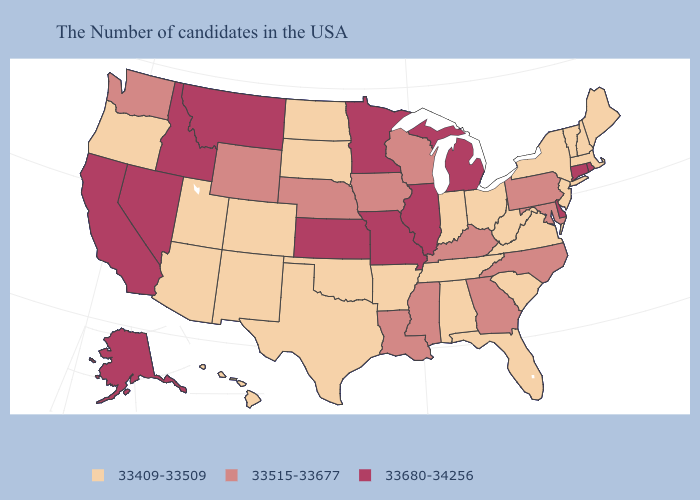What is the value of Minnesota?
Answer briefly. 33680-34256. Name the states that have a value in the range 33680-34256?
Concise answer only. Rhode Island, Connecticut, Delaware, Michigan, Illinois, Missouri, Minnesota, Kansas, Montana, Idaho, Nevada, California, Alaska. Which states have the highest value in the USA?
Quick response, please. Rhode Island, Connecticut, Delaware, Michigan, Illinois, Missouri, Minnesota, Kansas, Montana, Idaho, Nevada, California, Alaska. What is the value of Massachusetts?
Keep it brief. 33409-33509. Does North Dakota have the highest value in the MidWest?
Quick response, please. No. What is the value of Louisiana?
Write a very short answer. 33515-33677. Does Vermont have the same value as Oregon?
Short answer required. Yes. What is the value of Mississippi?
Be succinct. 33515-33677. What is the highest value in the South ?
Write a very short answer. 33680-34256. Does the map have missing data?
Keep it brief. No. What is the lowest value in the Northeast?
Short answer required. 33409-33509. Does the first symbol in the legend represent the smallest category?
Answer briefly. Yes. Name the states that have a value in the range 33515-33677?
Give a very brief answer. Maryland, Pennsylvania, North Carolina, Georgia, Kentucky, Wisconsin, Mississippi, Louisiana, Iowa, Nebraska, Wyoming, Washington. Among the states that border Georgia , does Florida have the lowest value?
Be succinct. Yes. 